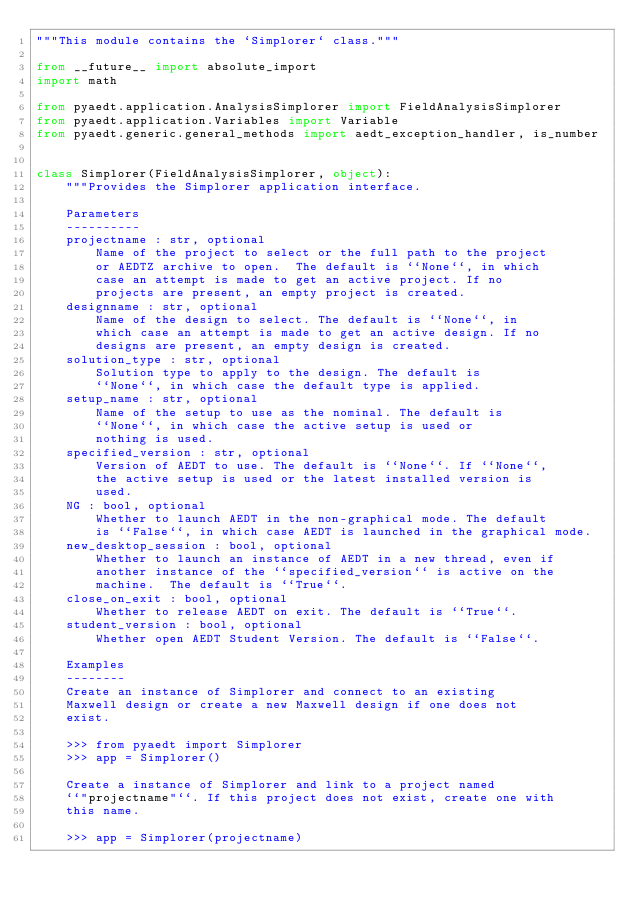Convert code to text. <code><loc_0><loc_0><loc_500><loc_500><_Python_>"""This module contains the `Simplorer` class."""

from __future__ import absolute_import
import math

from pyaedt.application.AnalysisSimplorer import FieldAnalysisSimplorer
from pyaedt.application.Variables import Variable
from pyaedt.generic.general_methods import aedt_exception_handler, is_number


class Simplorer(FieldAnalysisSimplorer, object):
    """Provides the Simplorer application interface.

    Parameters
    ----------
    projectname : str, optional
        Name of the project to select or the full path to the project
        or AEDTZ archive to open.  The default is ``None``, in which
        case an attempt is made to get an active project. If no
        projects are present, an empty project is created.
    designname : str, optional
        Name of the design to select. The default is ``None``, in
        which case an attempt is made to get an active design. If no
        designs are present, an empty design is created.
    solution_type : str, optional
        Solution type to apply to the design. The default is
        ``None``, in which case the default type is applied.
    setup_name : str, optional
        Name of the setup to use as the nominal. The default is
        ``None``, in which case the active setup is used or
        nothing is used.
    specified_version : str, optional
        Version of AEDT to use. The default is ``None``. If ``None``,
        the active setup is used or the latest installed version is
        used.
    NG : bool, optional
        Whether to launch AEDT in the non-graphical mode. The default
        is ``False``, in which case AEDT is launched in the graphical mode.
    new_desktop_session : bool, optional
        Whether to launch an instance of AEDT in a new thread, even if
        another instance of the ``specified_version`` is active on the
        machine.  The default is ``True``.
    close_on_exit : bool, optional
        Whether to release AEDT on exit. The default is ``True``.
    student_version : bool, optional
        Whether open AEDT Student Version. The default is ``False``.

    Examples
    --------
    Create an instance of Simplorer and connect to an existing
    Maxwell design or create a new Maxwell design if one does not
    exist.

    >>> from pyaedt import Simplorer
    >>> app = Simplorer()

    Create a instance of Simplorer and link to a project named
    ``"projectname"``. If this project does not exist, create one with
    this name.

    >>> app = Simplorer(projectname)
</code> 